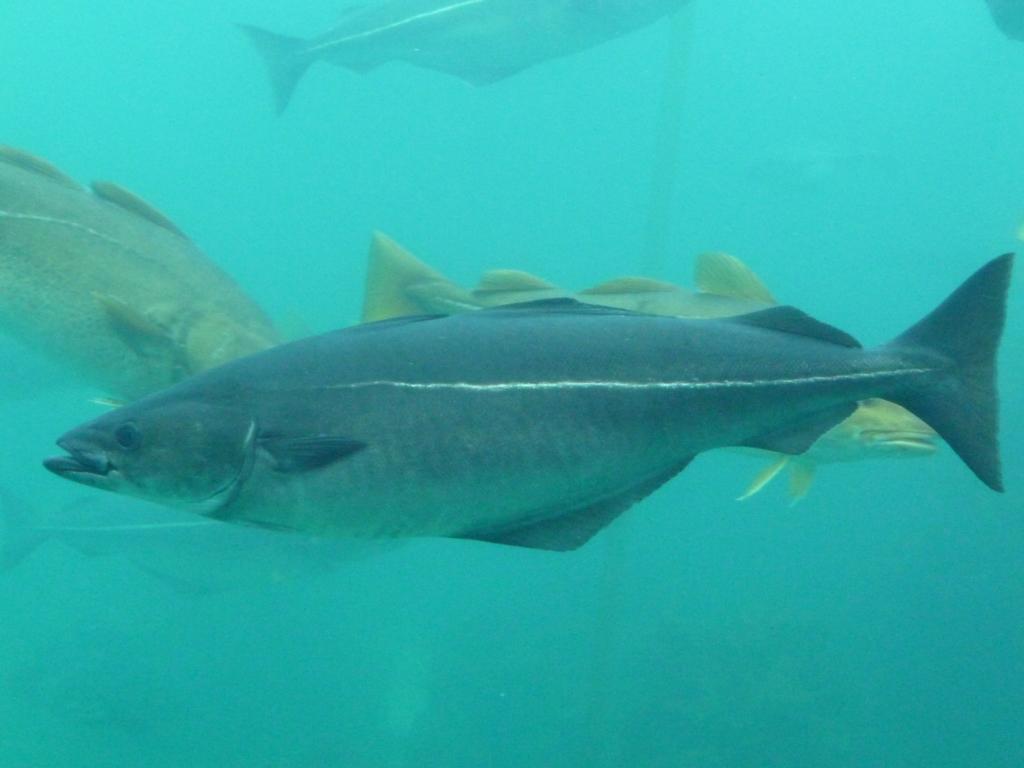Please provide a concise description of this image. In this picture we can see fish in the water. 